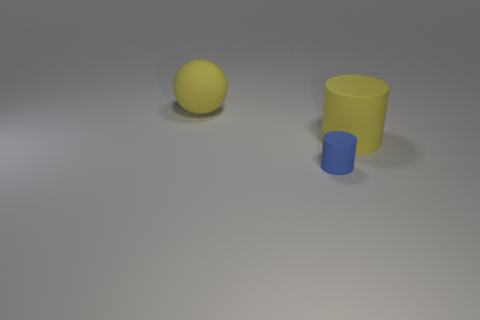Add 3 yellow rubber cubes. How many objects exist? 6 Subtract 0 green cubes. How many objects are left? 3 Subtract all cylinders. How many objects are left? 1 Subtract all red spheres. Subtract all blue blocks. How many spheres are left? 1 Subtract all gray spheres. How many blue cylinders are left? 1 Subtract all big yellow objects. Subtract all small things. How many objects are left? 0 Add 1 yellow spheres. How many yellow spheres are left? 2 Add 2 rubber cylinders. How many rubber cylinders exist? 4 